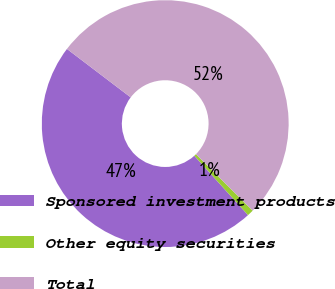Convert chart. <chart><loc_0><loc_0><loc_500><loc_500><pie_chart><fcel>Sponsored investment products<fcel>Other equity securities<fcel>Total<nl><fcel>47.05%<fcel>0.83%<fcel>52.12%<nl></chart> 